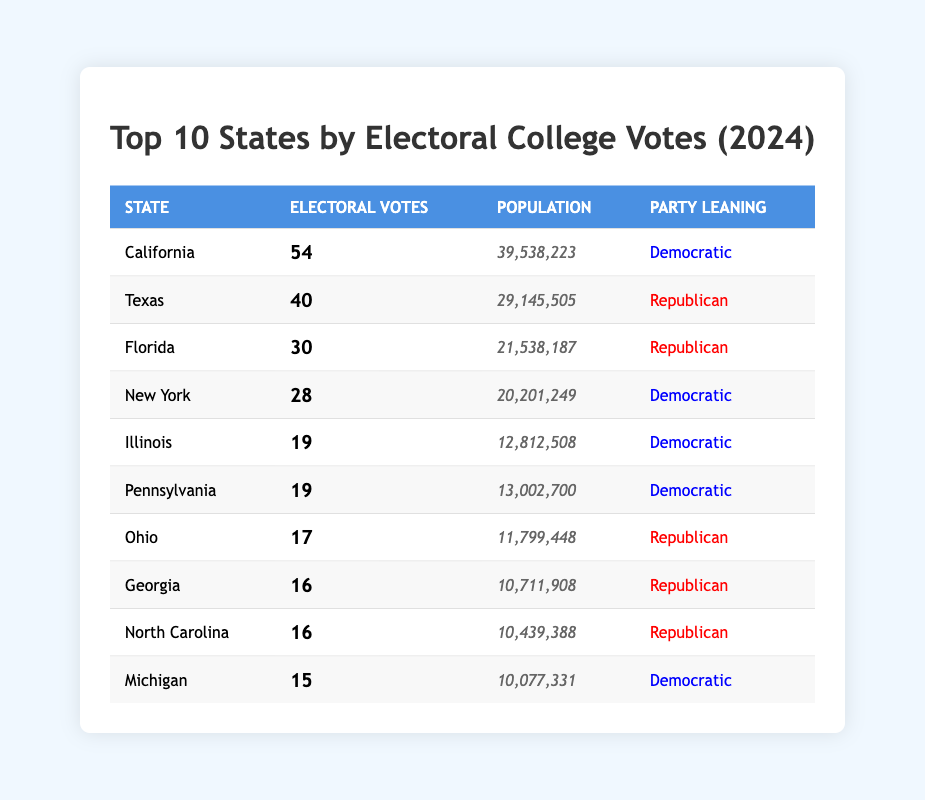What is the total number of electoral votes for all states combined in the table? To find the total, we add the electoral votes for each state: 54 (California) + 40 (Texas) + 30 (Florida) + 28 (New York) + 19 (Illinois) + 19 (Pennsylvania) + 17 (Ohio) + 16 (Georgia) + 16 (North Carolina) + 15 (Michigan) =  284.
Answer: 284 Which state has the highest number of electoral votes? Looking at the table, California has the highest value of electoral votes at 54.
Answer: California Is Pennsylvania a Democratic-leaning state based on its electoral votes? The table indicates Pennsylvania has a party leaning of Democratic, which confirms that it is indeed a Democratic-leaning state.
Answer: Yes What is the average number of electoral votes among the Republican states listed? The Republican states and their votes are Texas (40), Florida (30), Ohio (17), Georgia (16), and North Carolina (16). The total for these states is 119. There are 5 Republican states, so the average is 119/5 = 23.8.
Answer: 23.8 How many states in the table have more than 20 million in population? Analyzing the population figures, California (39,538,223), Texas (29,145,505), Florida (21,538,187), and New York (20,201,249) all exceed 20 million. In total, there are 4 states with populations exceeding 20 million.
Answer: 4 What is the combined electoral votes for Democratic-leaning states? The Democratic states and their votes are California (54), New York (28), Illinois (19), Pennsylvania (19), and Michigan (15). Adding these gives: 54 + 28 + 19 + 19 + 15 = 135.
Answer: 135 True or false: Florida has more electoral votes than New York. The table shows Florida has 30 electoral votes, while New York has 28. Therefore, the statement is true.
Answer: True Which state has the lowest number of electoral votes in the table? Looking closely at the table, the state with the lowest listed electoral votes is Michigan, which has 15 votes.
Answer: Michigan What percentage of the total electoral votes does Texas contribute? To find Texas's percentage, first compute its contribution: 40 votes out of a total of 284 gives (40/284) * 100 = 14.1. This is approximately 14.1%.
Answer: 14.1% 